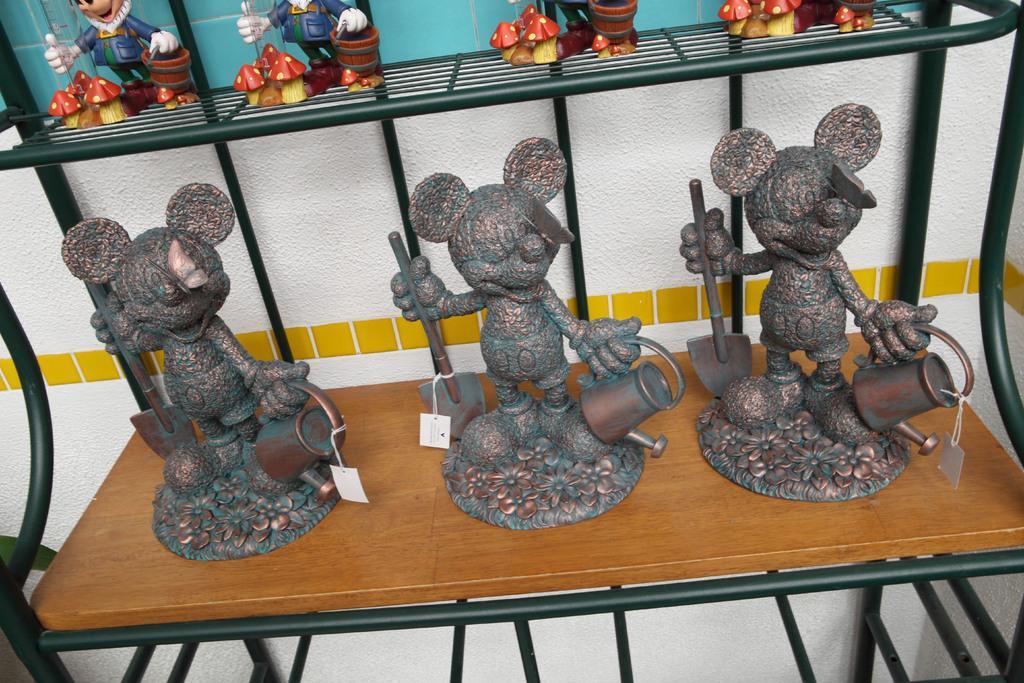Describe this image in one or two sentences. In this picture, we see three toys are placed on the table. These toys have price tags. Behind that, we see a white wall. At the top, we see four toys are placed in the rack. In the background, we see a blue wall. 